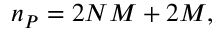<formula> <loc_0><loc_0><loc_500><loc_500>n _ { P } = 2 N M + 2 M ,</formula> 